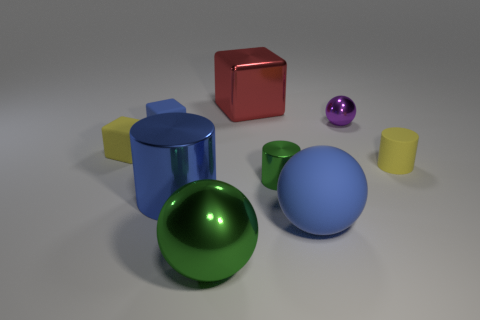Add 1 blue cylinders. How many objects exist? 10 Subtract all spheres. How many objects are left? 6 Subtract 0 purple blocks. How many objects are left? 9 Subtract all tiny yellow cubes. Subtract all tiny rubber cylinders. How many objects are left? 7 Add 8 blue shiny cylinders. How many blue shiny cylinders are left? 9 Add 5 yellow rubber objects. How many yellow rubber objects exist? 7 